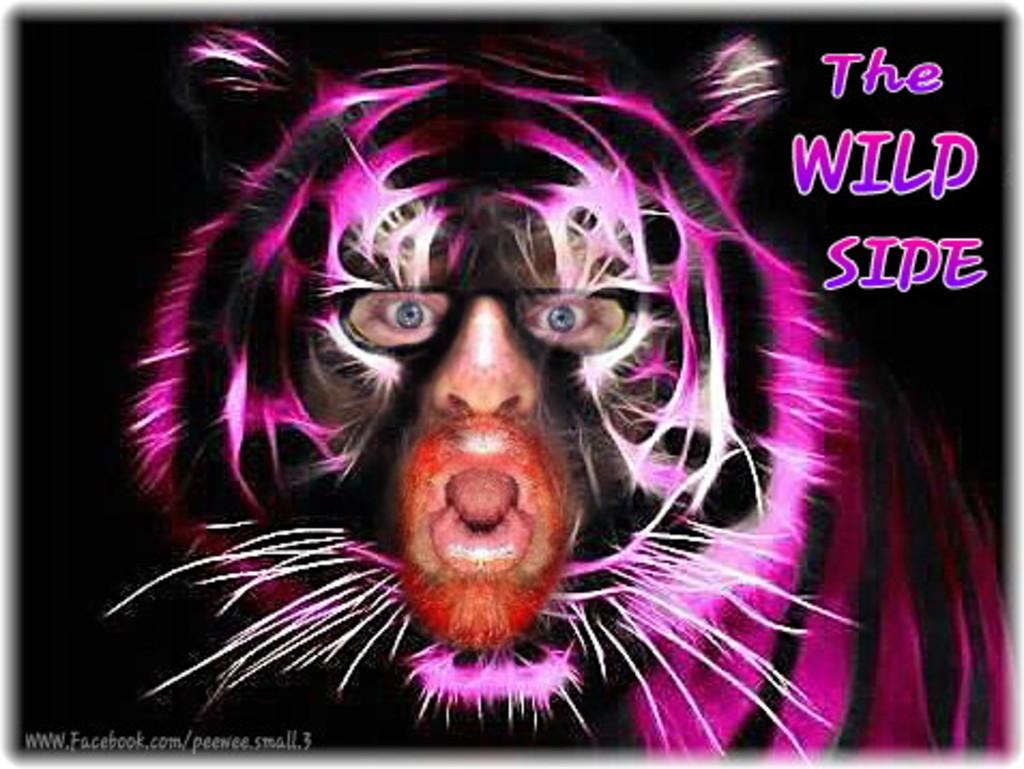What is present in the image that features a design or message? There is a poster in the image. What type of character is depicted on the poster? The poster features an animated animal. What else can be found on the poster besides the image? There is text written on the poster. How much does the daughter weigh in the image? There is no daughter present in the image; it only features a poster with an animated animal and text. 